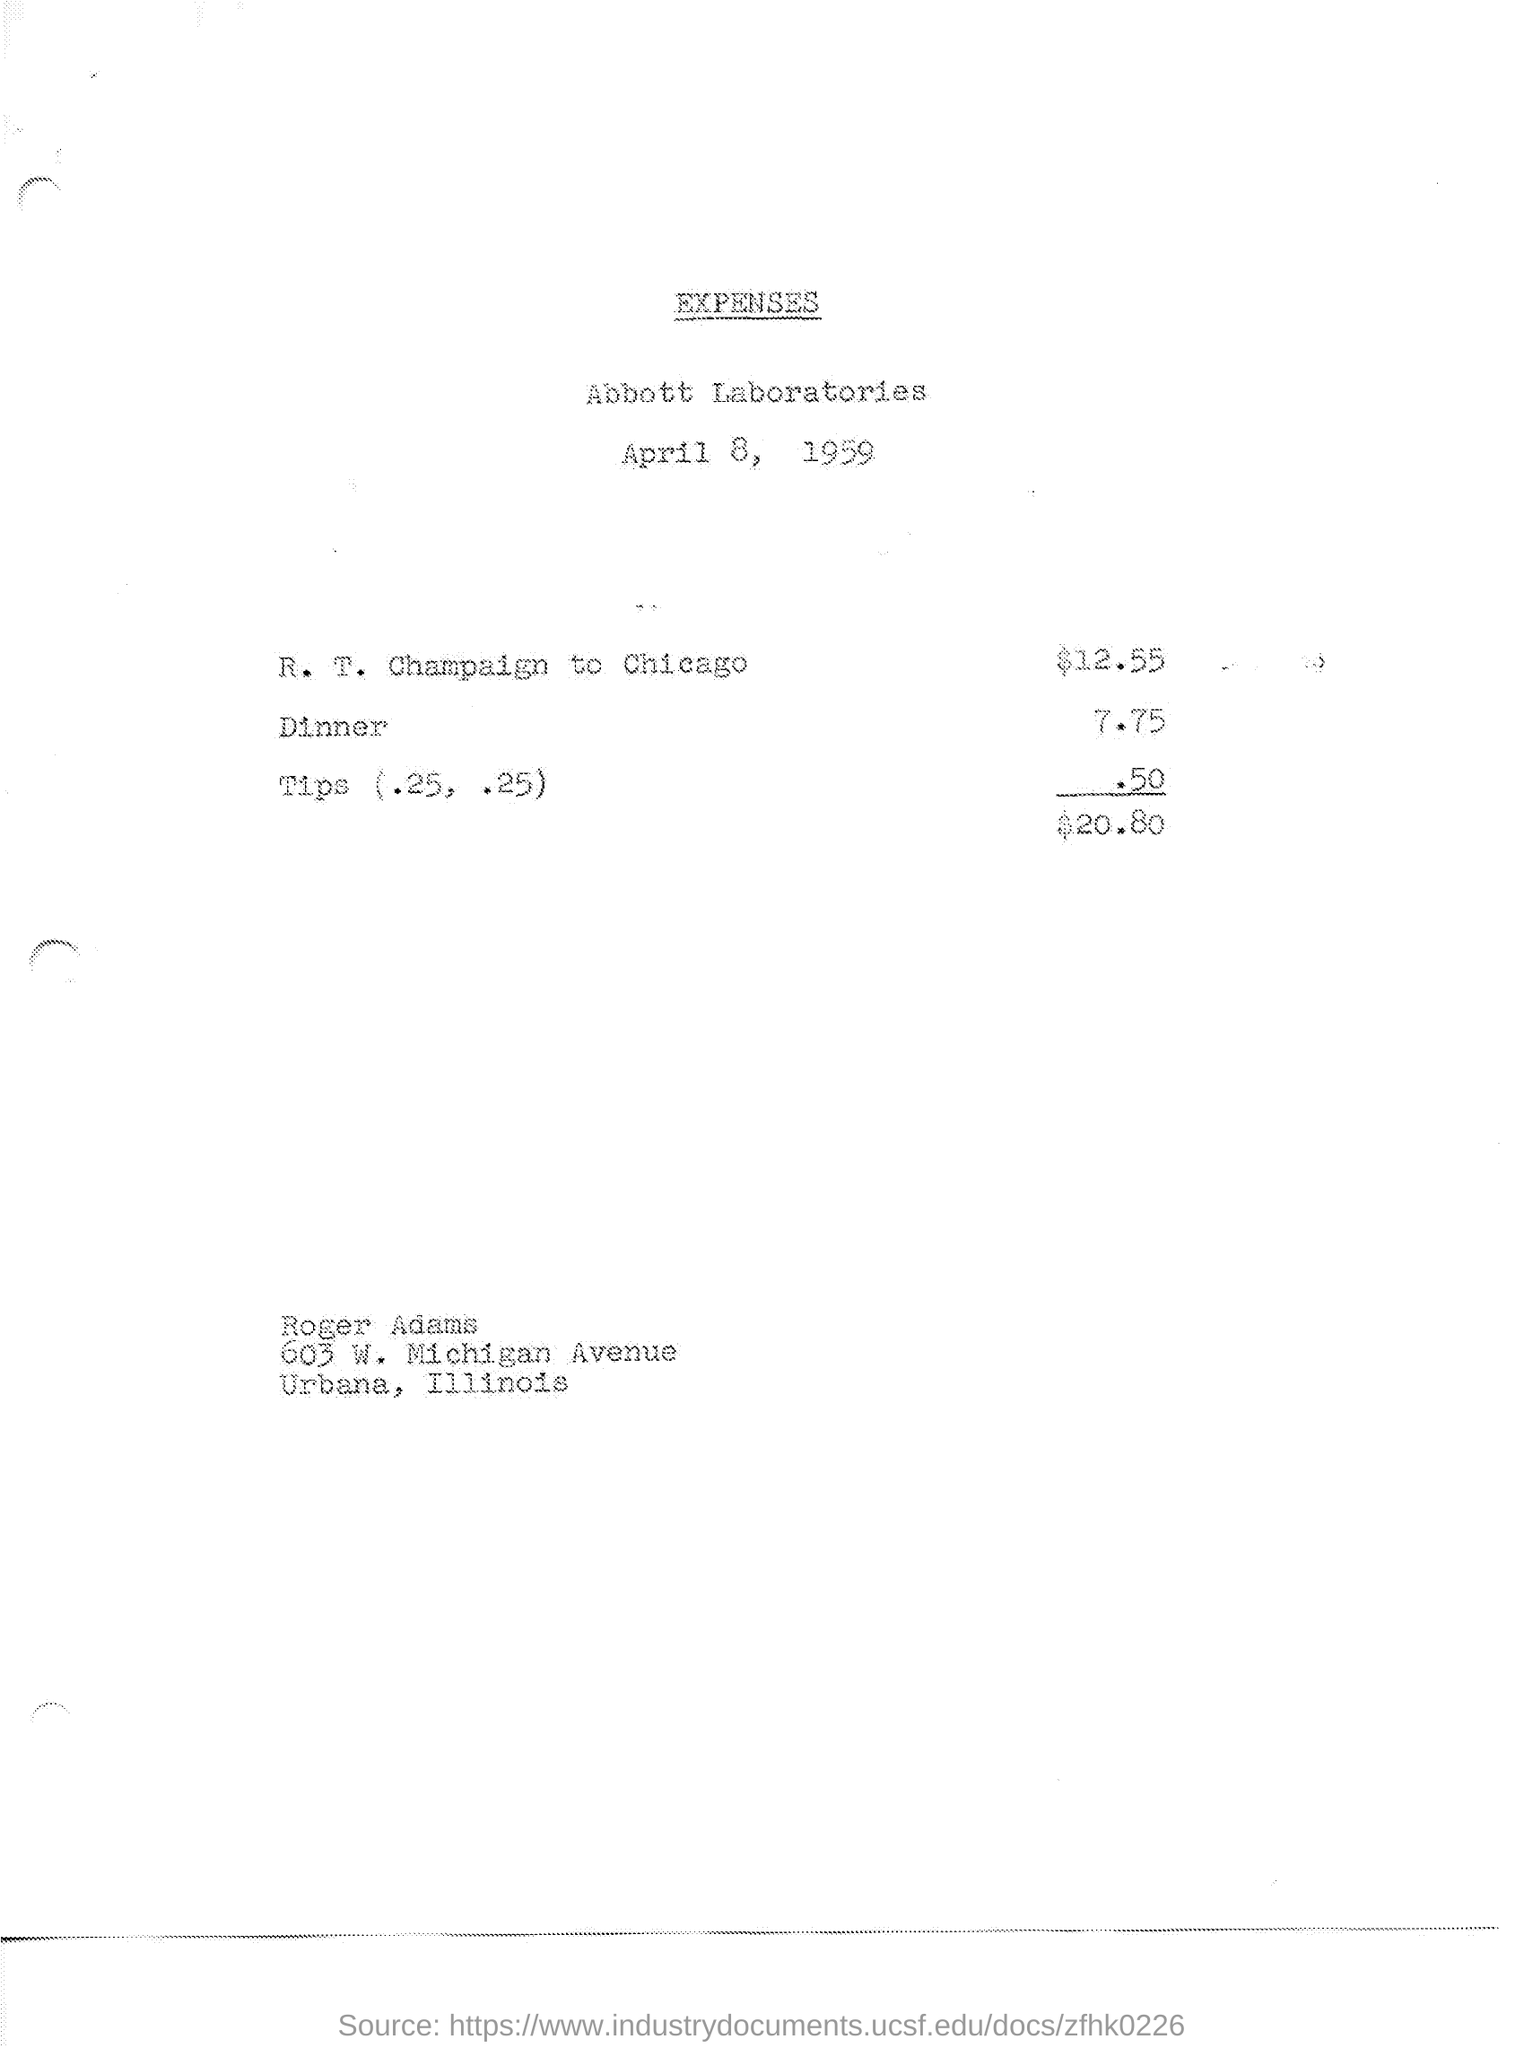What is the date of the document?
Your response must be concise. April 8, 1959. What is cost of dinner?
Provide a succinct answer. 7.75. What is tips amount?
Give a very brief answer. .50. What is R.T Champaign to Chicago
Your answer should be very brief. $12.55. 